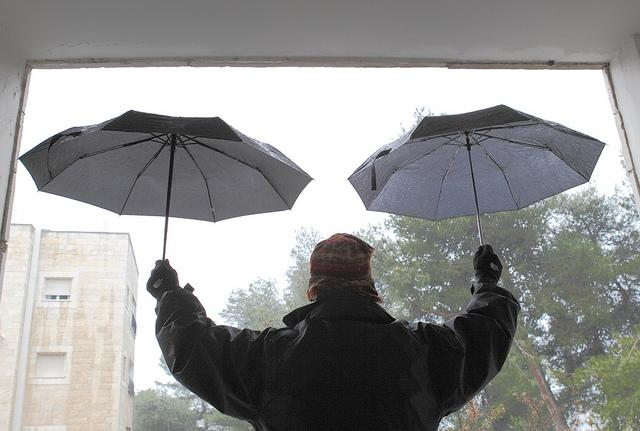What weather is being encountered here?

Choices:
A) rain
B) snow
C) sun
D) sleet rain 